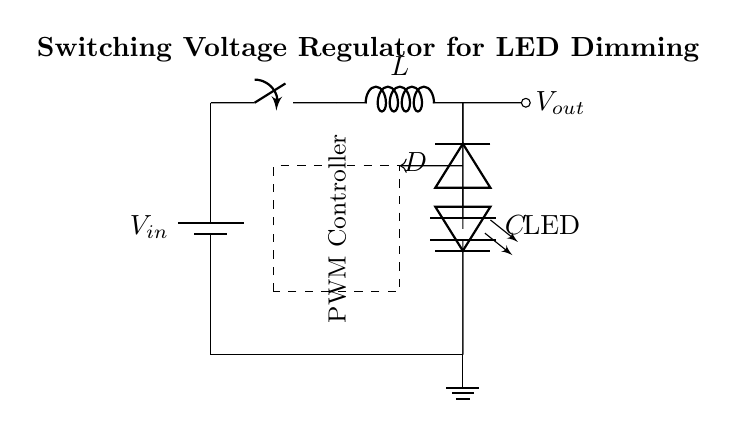What is the primary function of this circuit? The circuit is designed for voltage regulation, specifically for energy-efficient dimming of LED lighting fixtures. It achieves this by using a PWM controller to adjust the output voltage based on the needs of the load.
Answer: Voltage regulation What component is responsible for the energy storage in this circuit? The inductor is responsible for storing energy in this circuit. It stores energy when current flows through it and releases it when the current decreases, smoothing out the voltage to the load.
Answer: Inductor What does PWM stand for in this circuit? PWM stands for Pulse Width Modulation. It is a technique used by the controller to regulate the output voltage by varying the width of the voltage pulses to control the power delivered to the LED load.
Answer: Pulse Width Modulation How many types of components are present in this circuit? The circuit contains four types of components: a battery, a switch, an inductor, a diode, a capacitor, an LED, and a PWM controller. Therefore, the total number of unique component types is seven.
Answer: Seven Where is feedback implemented in this circuit? Feedback is implemented in the dotted line from the output (top of the capacitor) to the PWM controller area, allowing the circuit to adjust the output voltage based on the load conditions.
Answer: Dotted line from output to PWM controller What is the likely role of the diode in this circuit? The diode allows current to flow in one direction only, which protects the circuit from potential reverse currents that could damage the components. It ensures that the energy stored in the inductor can discharge into the load while preventing backflow.
Answer: Protection 